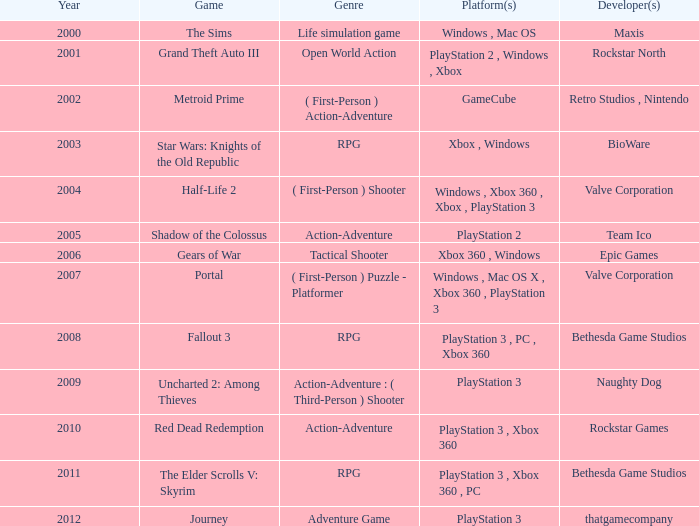What game was in 2001? Grand Theft Auto III. 